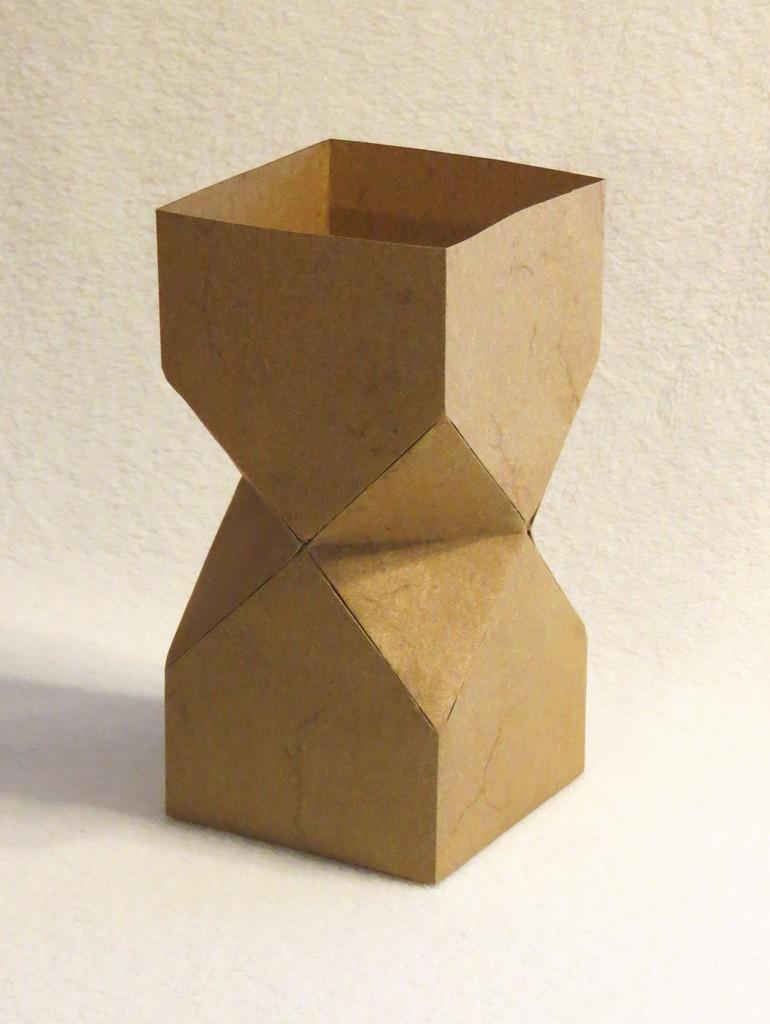Can you describe this image briefly? In this image there is a cardboard shaped in a prism. 